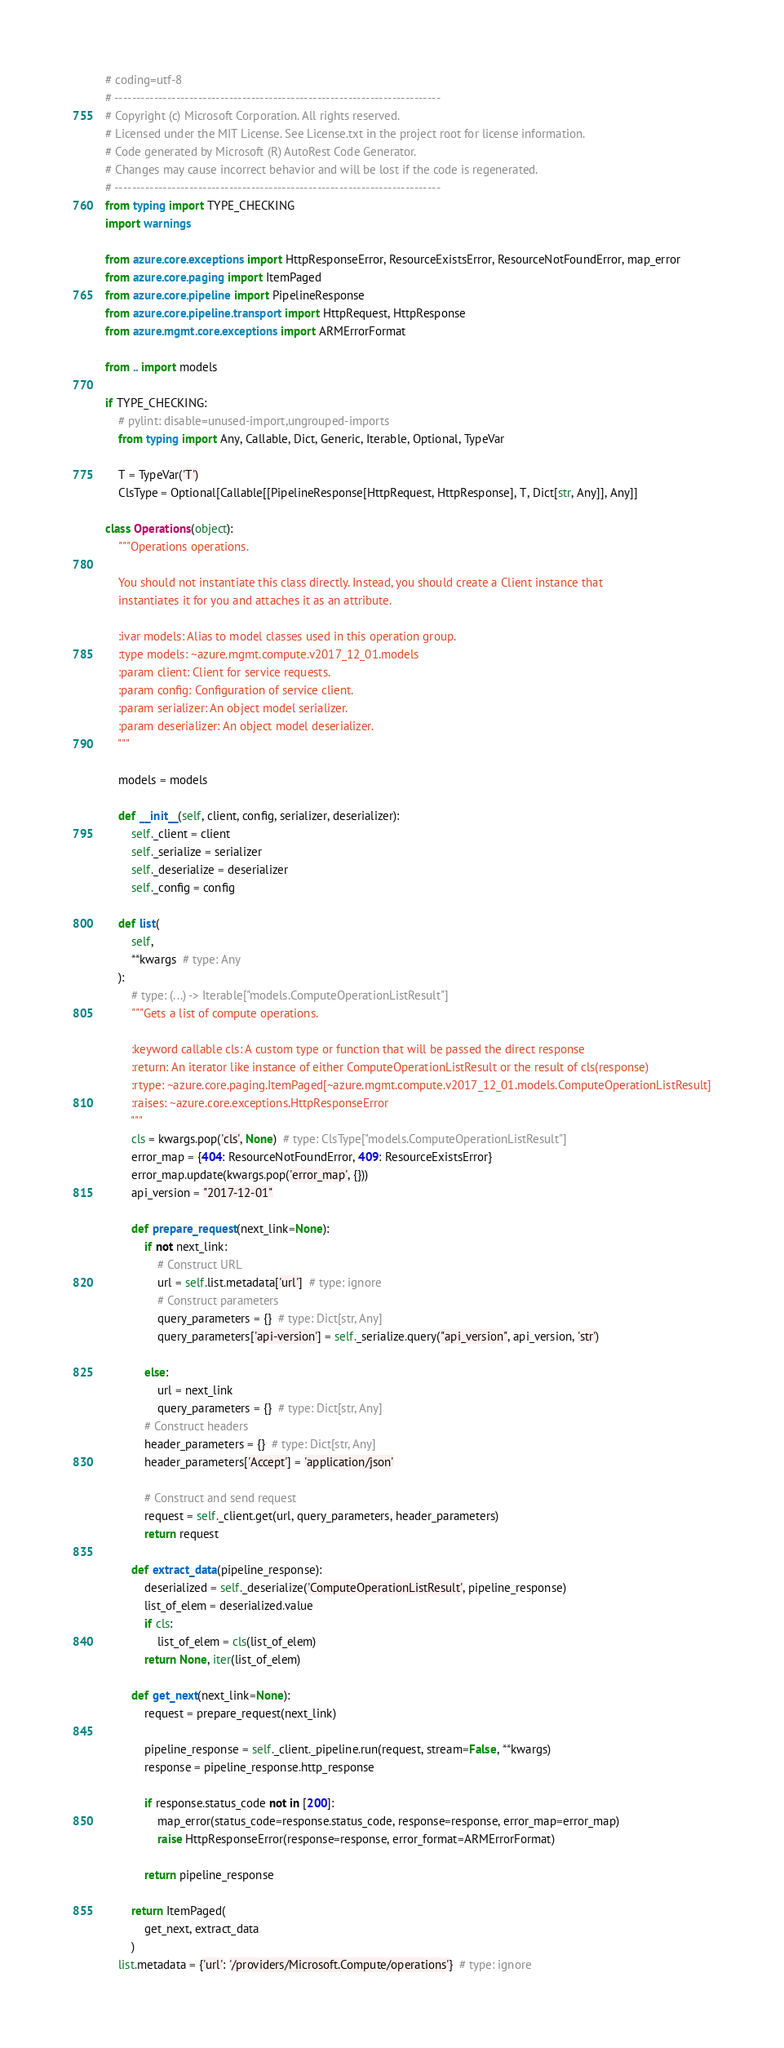<code> <loc_0><loc_0><loc_500><loc_500><_Python_># coding=utf-8
# --------------------------------------------------------------------------
# Copyright (c) Microsoft Corporation. All rights reserved.
# Licensed under the MIT License. See License.txt in the project root for license information.
# Code generated by Microsoft (R) AutoRest Code Generator.
# Changes may cause incorrect behavior and will be lost if the code is regenerated.
# --------------------------------------------------------------------------
from typing import TYPE_CHECKING
import warnings

from azure.core.exceptions import HttpResponseError, ResourceExistsError, ResourceNotFoundError, map_error
from azure.core.paging import ItemPaged
from azure.core.pipeline import PipelineResponse
from azure.core.pipeline.transport import HttpRequest, HttpResponse
from azure.mgmt.core.exceptions import ARMErrorFormat

from .. import models

if TYPE_CHECKING:
    # pylint: disable=unused-import,ungrouped-imports
    from typing import Any, Callable, Dict, Generic, Iterable, Optional, TypeVar

    T = TypeVar('T')
    ClsType = Optional[Callable[[PipelineResponse[HttpRequest, HttpResponse], T, Dict[str, Any]], Any]]

class Operations(object):
    """Operations operations.

    You should not instantiate this class directly. Instead, you should create a Client instance that
    instantiates it for you and attaches it as an attribute.

    :ivar models: Alias to model classes used in this operation group.
    :type models: ~azure.mgmt.compute.v2017_12_01.models
    :param client: Client for service requests.
    :param config: Configuration of service client.
    :param serializer: An object model serializer.
    :param deserializer: An object model deserializer.
    """

    models = models

    def __init__(self, client, config, serializer, deserializer):
        self._client = client
        self._serialize = serializer
        self._deserialize = deserializer
        self._config = config

    def list(
        self,
        **kwargs  # type: Any
    ):
        # type: (...) -> Iterable["models.ComputeOperationListResult"]
        """Gets a list of compute operations.

        :keyword callable cls: A custom type or function that will be passed the direct response
        :return: An iterator like instance of either ComputeOperationListResult or the result of cls(response)
        :rtype: ~azure.core.paging.ItemPaged[~azure.mgmt.compute.v2017_12_01.models.ComputeOperationListResult]
        :raises: ~azure.core.exceptions.HttpResponseError
        """
        cls = kwargs.pop('cls', None)  # type: ClsType["models.ComputeOperationListResult"]
        error_map = {404: ResourceNotFoundError, 409: ResourceExistsError}
        error_map.update(kwargs.pop('error_map', {}))
        api_version = "2017-12-01"

        def prepare_request(next_link=None):
            if not next_link:
                # Construct URL
                url = self.list.metadata['url']  # type: ignore
                # Construct parameters
                query_parameters = {}  # type: Dict[str, Any]
                query_parameters['api-version'] = self._serialize.query("api_version", api_version, 'str')

            else:
                url = next_link
                query_parameters = {}  # type: Dict[str, Any]
            # Construct headers
            header_parameters = {}  # type: Dict[str, Any]
            header_parameters['Accept'] = 'application/json'

            # Construct and send request
            request = self._client.get(url, query_parameters, header_parameters)
            return request

        def extract_data(pipeline_response):
            deserialized = self._deserialize('ComputeOperationListResult', pipeline_response)
            list_of_elem = deserialized.value
            if cls:
                list_of_elem = cls(list_of_elem)
            return None, iter(list_of_elem)

        def get_next(next_link=None):
            request = prepare_request(next_link)

            pipeline_response = self._client._pipeline.run(request, stream=False, **kwargs)
            response = pipeline_response.http_response

            if response.status_code not in [200]:
                map_error(status_code=response.status_code, response=response, error_map=error_map)
                raise HttpResponseError(response=response, error_format=ARMErrorFormat)

            return pipeline_response

        return ItemPaged(
            get_next, extract_data
        )
    list.metadata = {'url': '/providers/Microsoft.Compute/operations'}  # type: ignore
</code> 